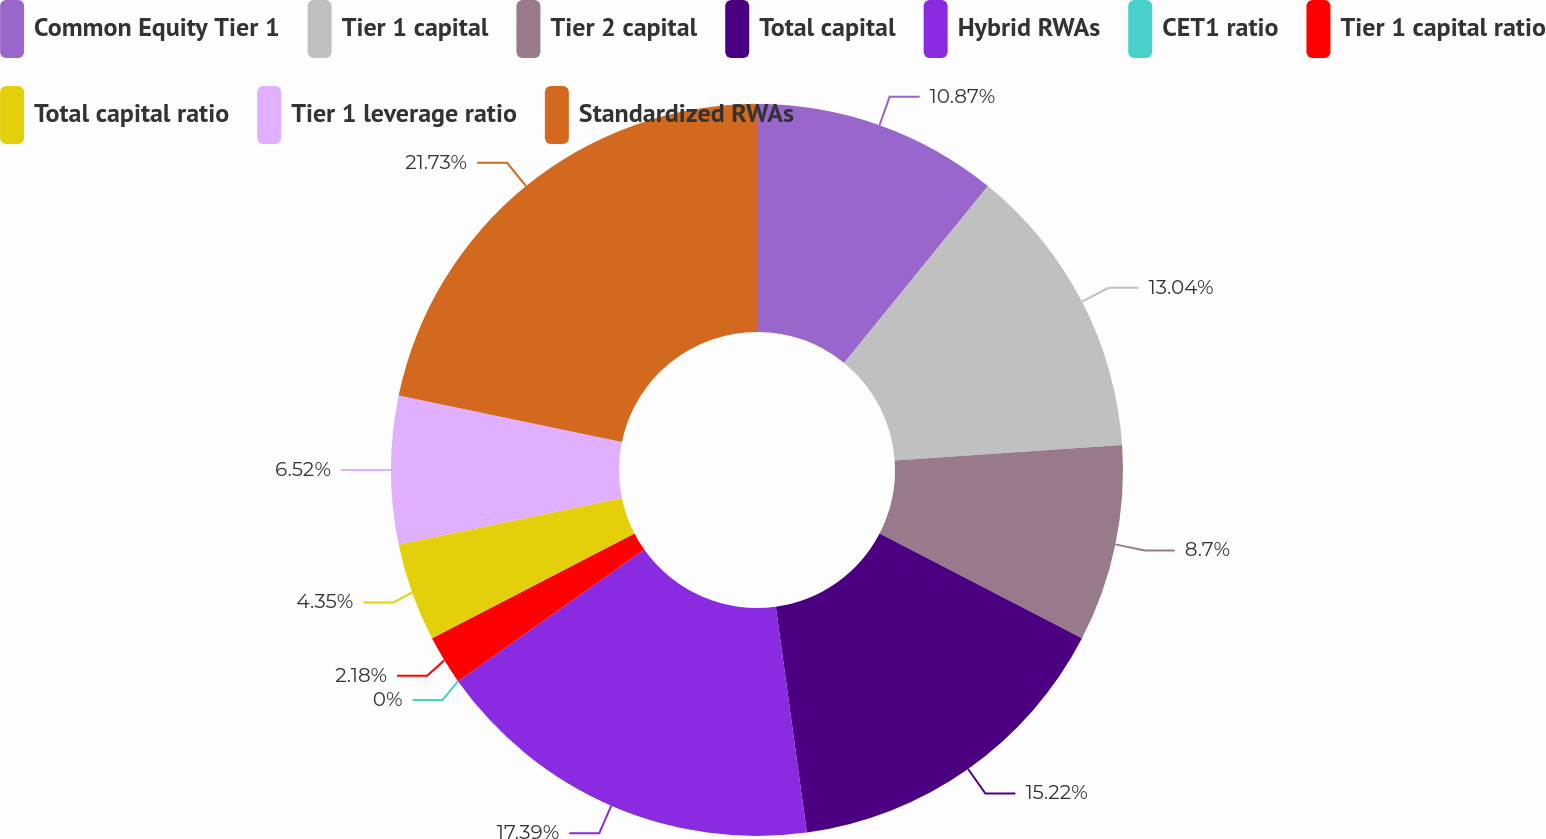Convert chart. <chart><loc_0><loc_0><loc_500><loc_500><pie_chart><fcel>Common Equity Tier 1<fcel>Tier 1 capital<fcel>Tier 2 capital<fcel>Total capital<fcel>Hybrid RWAs<fcel>CET1 ratio<fcel>Tier 1 capital ratio<fcel>Total capital ratio<fcel>Tier 1 leverage ratio<fcel>Standardized RWAs<nl><fcel>10.87%<fcel>13.04%<fcel>8.7%<fcel>15.22%<fcel>17.39%<fcel>0.0%<fcel>2.18%<fcel>4.35%<fcel>6.52%<fcel>21.74%<nl></chart> 